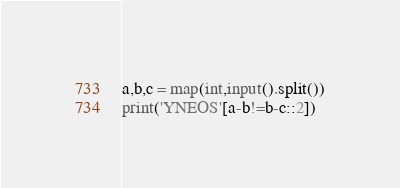Convert code to text. <code><loc_0><loc_0><loc_500><loc_500><_Python_>a,b,c = map(int,input().split())
print('YNEOS'[a-b!=b-c::2])
</code> 